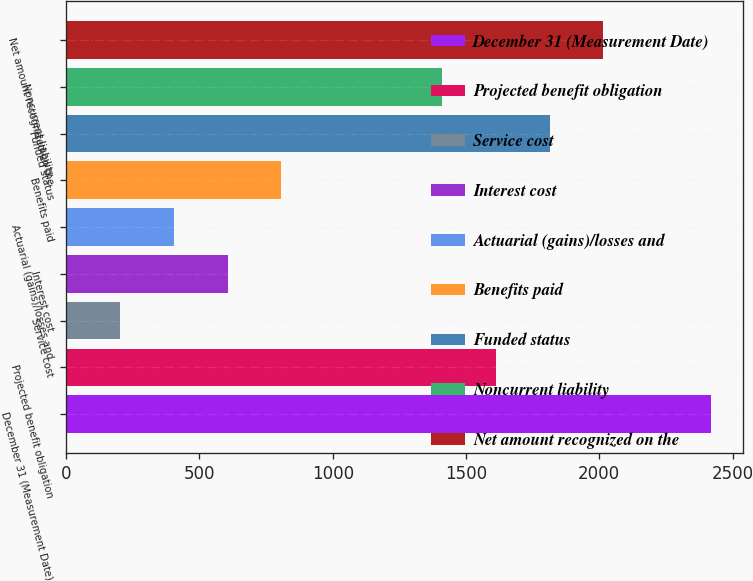Convert chart. <chart><loc_0><loc_0><loc_500><loc_500><bar_chart><fcel>December 31 (Measurement Date)<fcel>Projected benefit obligation<fcel>Service cost<fcel>Interest cost<fcel>Actuarial (gains)/losses and<fcel>Benefits paid<fcel>Funded status<fcel>Noncurrent liability<fcel>Net amount recognized on the<nl><fcel>2417.8<fcel>1612.2<fcel>202.4<fcel>605.2<fcel>403.8<fcel>806.6<fcel>1813.6<fcel>1410.8<fcel>2015<nl></chart> 